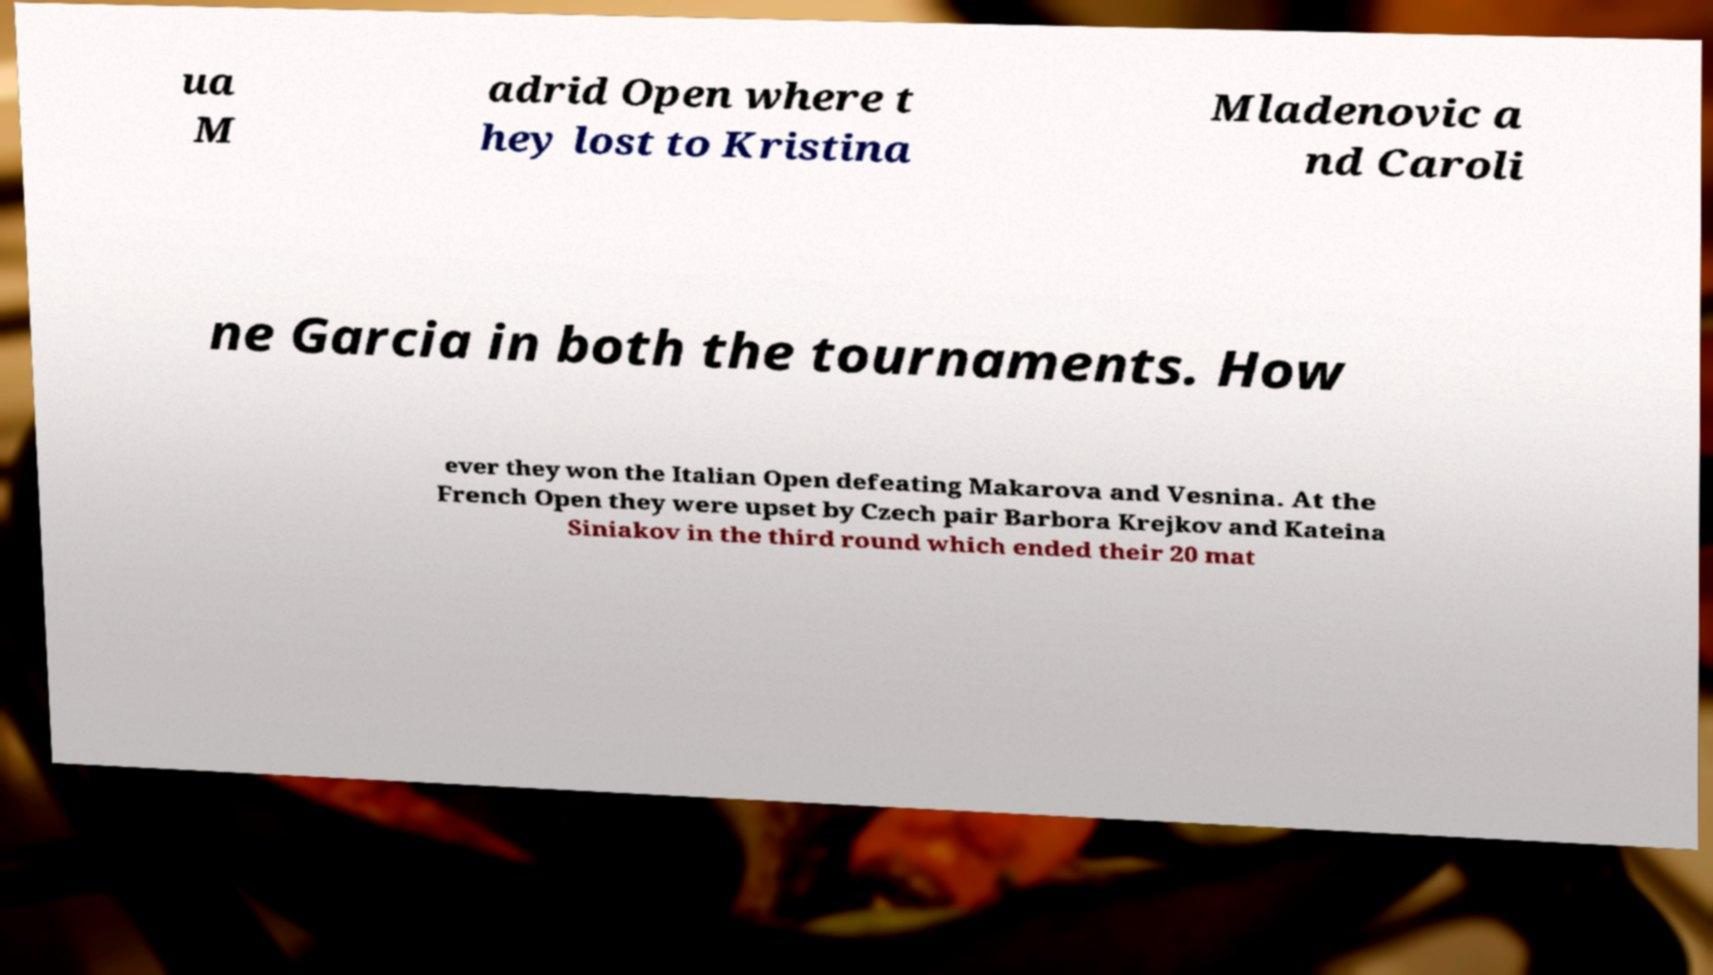For documentation purposes, I need the text within this image transcribed. Could you provide that? ua M adrid Open where t hey lost to Kristina Mladenovic a nd Caroli ne Garcia in both the tournaments. How ever they won the Italian Open defeating Makarova and Vesnina. At the French Open they were upset by Czech pair Barbora Krejkov and Kateina Siniakov in the third round which ended their 20 mat 